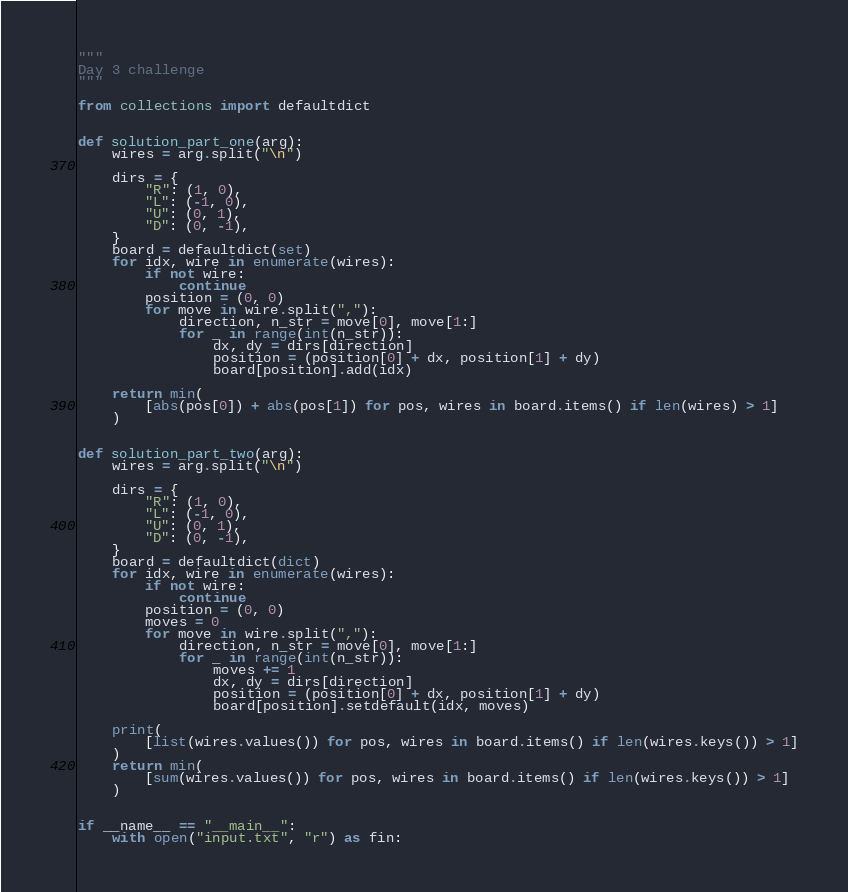Convert code to text. <code><loc_0><loc_0><loc_500><loc_500><_Python_>"""
Day 3 challenge
"""

from collections import defaultdict


def solution_part_one(arg):
    wires = arg.split("\n")

    dirs = {
        "R": (1, 0),
        "L": (-1, 0),
        "U": (0, 1),
        "D": (0, -1),
    }
    board = defaultdict(set)
    for idx, wire in enumerate(wires):
        if not wire:
            continue
        position = (0, 0)
        for move in wire.split(","):
            direction, n_str = move[0], move[1:]
            for _ in range(int(n_str)):
                dx, dy = dirs[direction]
                position = (position[0] + dx, position[1] + dy)
                board[position].add(idx)

    return min(
        [abs(pos[0]) + abs(pos[1]) for pos, wires in board.items() if len(wires) > 1]
    )


def solution_part_two(arg):
    wires = arg.split("\n")

    dirs = {
        "R": (1, 0),
        "L": (-1, 0),
        "U": (0, 1),
        "D": (0, -1),
    }
    board = defaultdict(dict)
    for idx, wire in enumerate(wires):
        if not wire:
            continue
        position = (0, 0)
        moves = 0
        for move in wire.split(","):
            direction, n_str = move[0], move[1:]
            for _ in range(int(n_str)):
                moves += 1
                dx, dy = dirs[direction]
                position = (position[0] + dx, position[1] + dy)
                board[position].setdefault(idx, moves)

    print(
        [list(wires.values()) for pos, wires in board.items() if len(wires.keys()) > 1]
    )
    return min(
        [sum(wires.values()) for pos, wires in board.items() if len(wires.keys()) > 1]
    )


if __name__ == "__main__":
    with open("input.txt", "r") as fin:</code> 